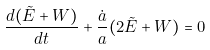Convert formula to latex. <formula><loc_0><loc_0><loc_500><loc_500>\frac { d ( \tilde { E } + W ) } { d t } + \frac { \dot { a } } { a } ( 2 \tilde { E } + W ) = 0</formula> 